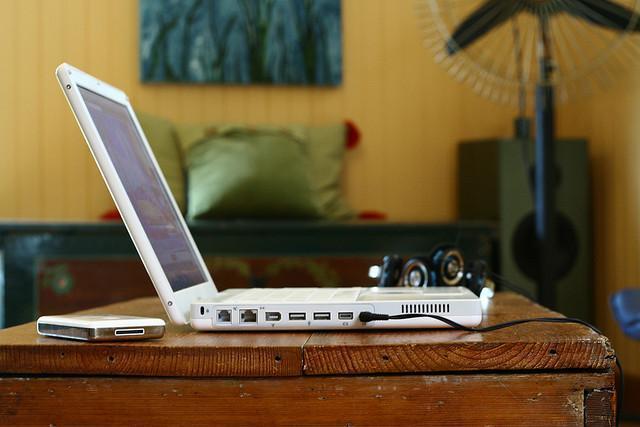How many laptops can be seen?
Give a very brief answer. 1. 